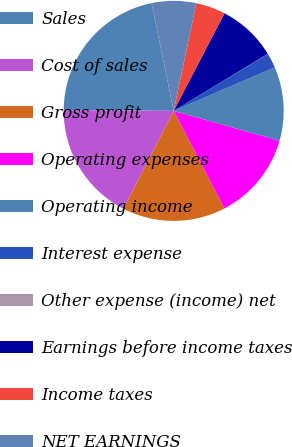Convert chart to OTSL. <chart><loc_0><loc_0><loc_500><loc_500><pie_chart><fcel>Sales<fcel>Cost of sales<fcel>Gross profit<fcel>Operating expenses<fcel>Operating income<fcel>Interest expense<fcel>Other expense (income) net<fcel>Earnings before income taxes<fcel>Income taxes<fcel>NET EARNINGS<nl><fcel>21.66%<fcel>17.57%<fcel>15.17%<fcel>13.01%<fcel>10.84%<fcel>2.19%<fcel>0.02%<fcel>8.68%<fcel>4.35%<fcel>6.51%<nl></chart> 